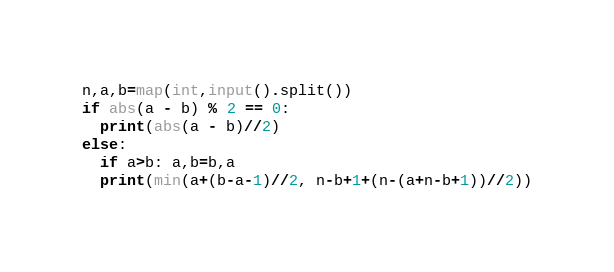Convert code to text. <code><loc_0><loc_0><loc_500><loc_500><_Cython_>n,a,b=map(int,input().split())
if abs(a - b) % 2 == 0:
  print(abs(a - b)//2)
else:
  if a>b: a,b=b,a
  print(min(a+(b-a-1)//2, n-b+1+(n-(a+n-b+1))//2))</code> 